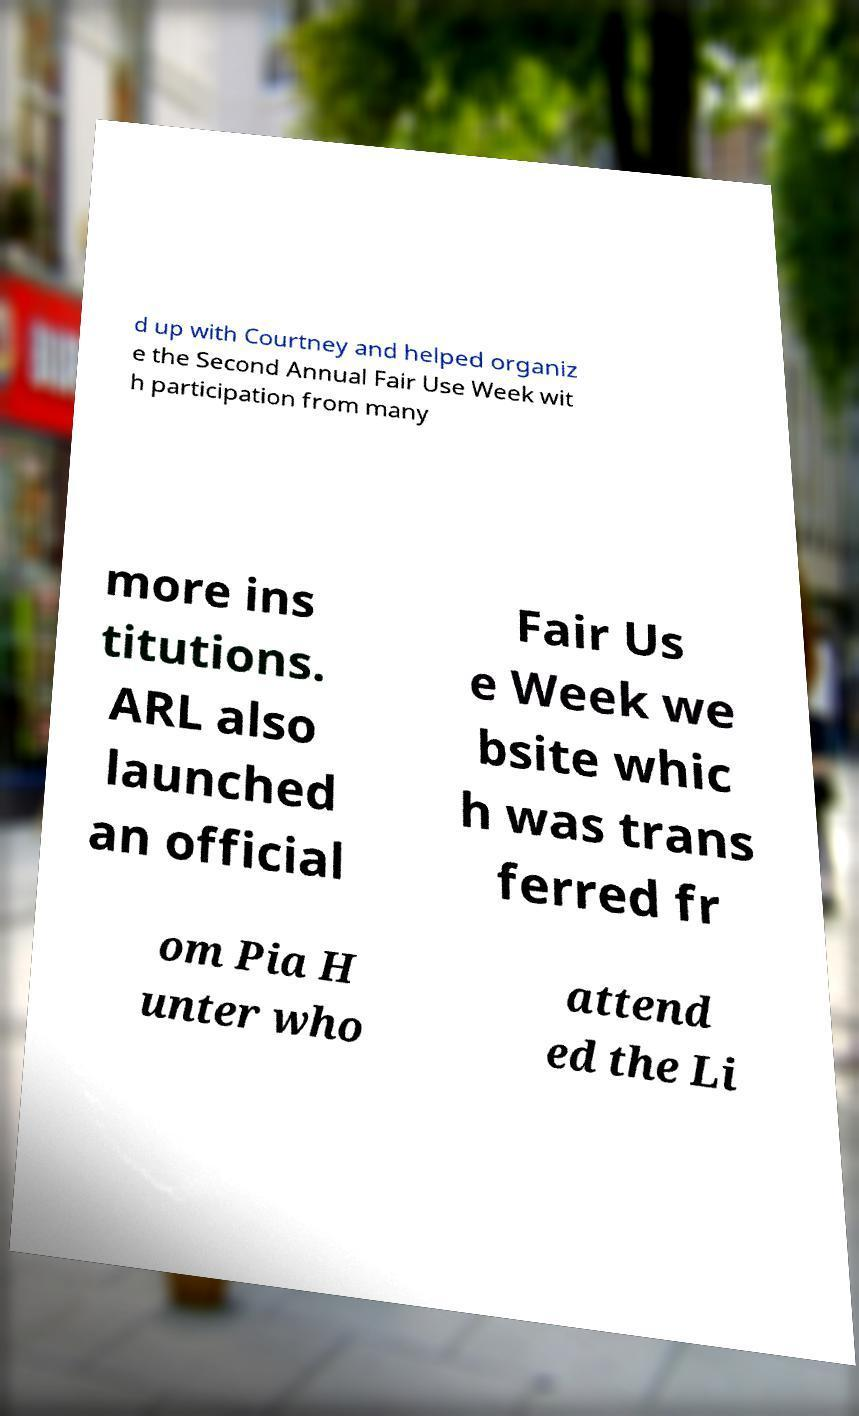There's text embedded in this image that I need extracted. Can you transcribe it verbatim? d up with Courtney and helped organiz e the Second Annual Fair Use Week wit h participation from many more ins titutions. ARL also launched an official Fair Us e Week we bsite whic h was trans ferred fr om Pia H unter who attend ed the Li 